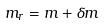<formula> <loc_0><loc_0><loc_500><loc_500>m _ { r } = m + \delta m</formula> 